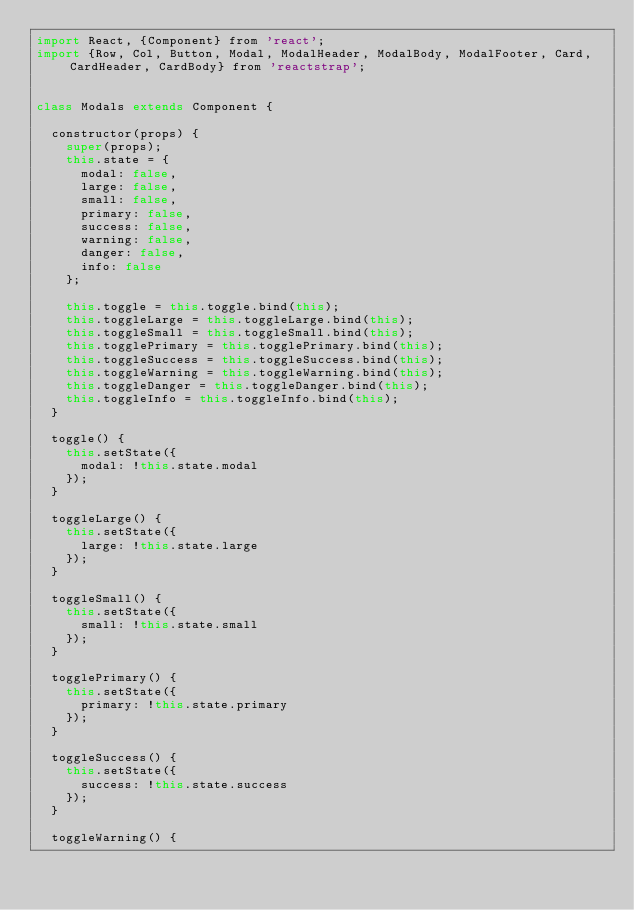Convert code to text. <code><loc_0><loc_0><loc_500><loc_500><_JavaScript_>import React, {Component} from 'react';
import {Row, Col, Button, Modal, ModalHeader, ModalBody, ModalFooter, Card, CardHeader, CardBody} from 'reactstrap';


class Modals extends Component {

  constructor(props) {
    super(props);
    this.state = {
      modal: false,
      large: false,
      small: false,
      primary: false,
      success: false,
      warning: false,
      danger: false,
      info: false
    };

    this.toggle = this.toggle.bind(this);
    this.toggleLarge = this.toggleLarge.bind(this);
    this.toggleSmall = this.toggleSmall.bind(this);
    this.togglePrimary = this.togglePrimary.bind(this);
    this.toggleSuccess = this.toggleSuccess.bind(this);
    this.toggleWarning = this.toggleWarning.bind(this);
    this.toggleDanger = this.toggleDanger.bind(this);
    this.toggleInfo = this.toggleInfo.bind(this);
  }

  toggle() {
    this.setState({
      modal: !this.state.modal
    });
  }

  toggleLarge() {
    this.setState({
      large: !this.state.large
    });
  }

  toggleSmall() {
    this.setState({
      small: !this.state.small
    });
  }

  togglePrimary() {
    this.setState({
      primary: !this.state.primary
    });
  }

  toggleSuccess() {
    this.setState({
      success: !this.state.success
    });
  }

  toggleWarning() {</code> 